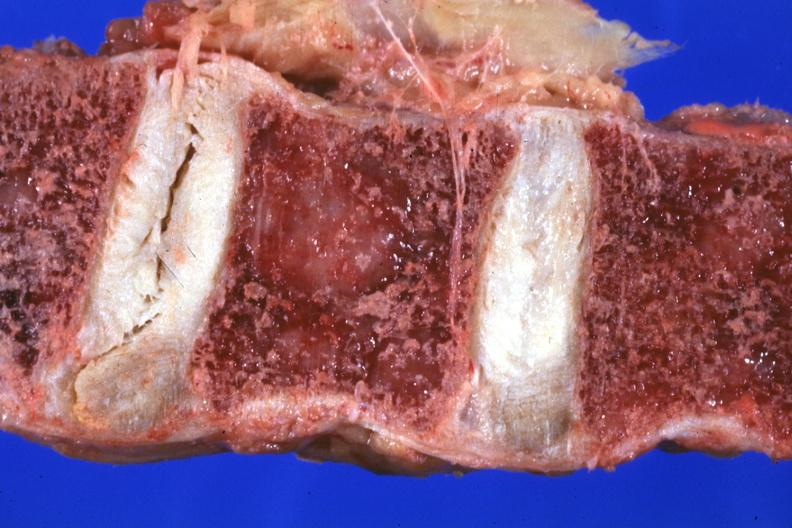s teeth present?
Answer the question using a single word or phrase. No 